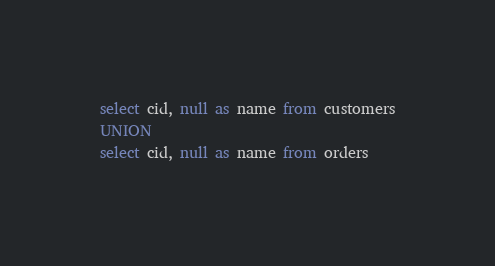Convert code to text. <code><loc_0><loc_0><loc_500><loc_500><_SQL_>select cid, null as name from customers
UNION
select cid, null as name from orders</code> 